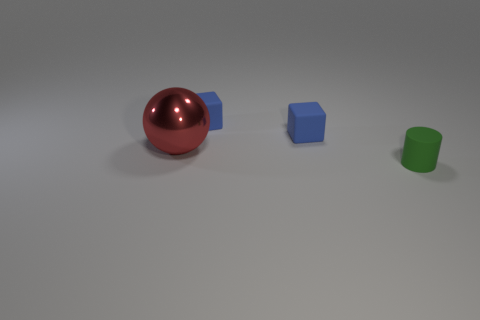Add 4 big cyan metal cylinders. How many objects exist? 8 Subtract all balls. How many objects are left? 3 Subtract 0 purple cylinders. How many objects are left? 4 Subtract all red spheres. Subtract all blue cubes. How many objects are left? 1 Add 1 small objects. How many small objects are left? 4 Add 1 tiny blue things. How many tiny blue things exist? 3 